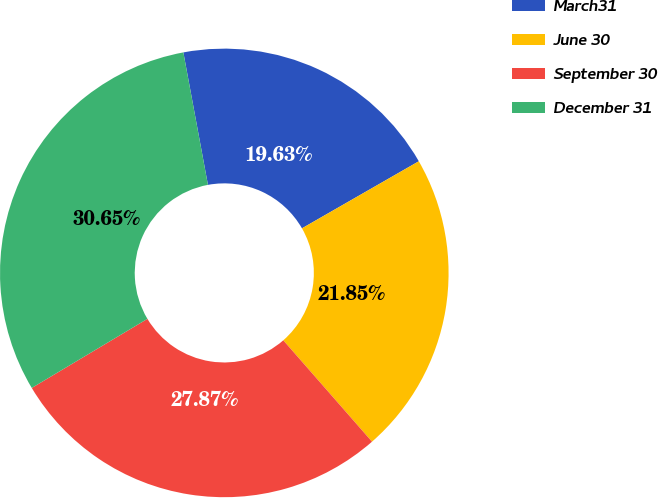<chart> <loc_0><loc_0><loc_500><loc_500><pie_chart><fcel>March31<fcel>June 30<fcel>September 30<fcel>December 31<nl><fcel>19.63%<fcel>21.85%<fcel>27.87%<fcel>30.65%<nl></chart> 